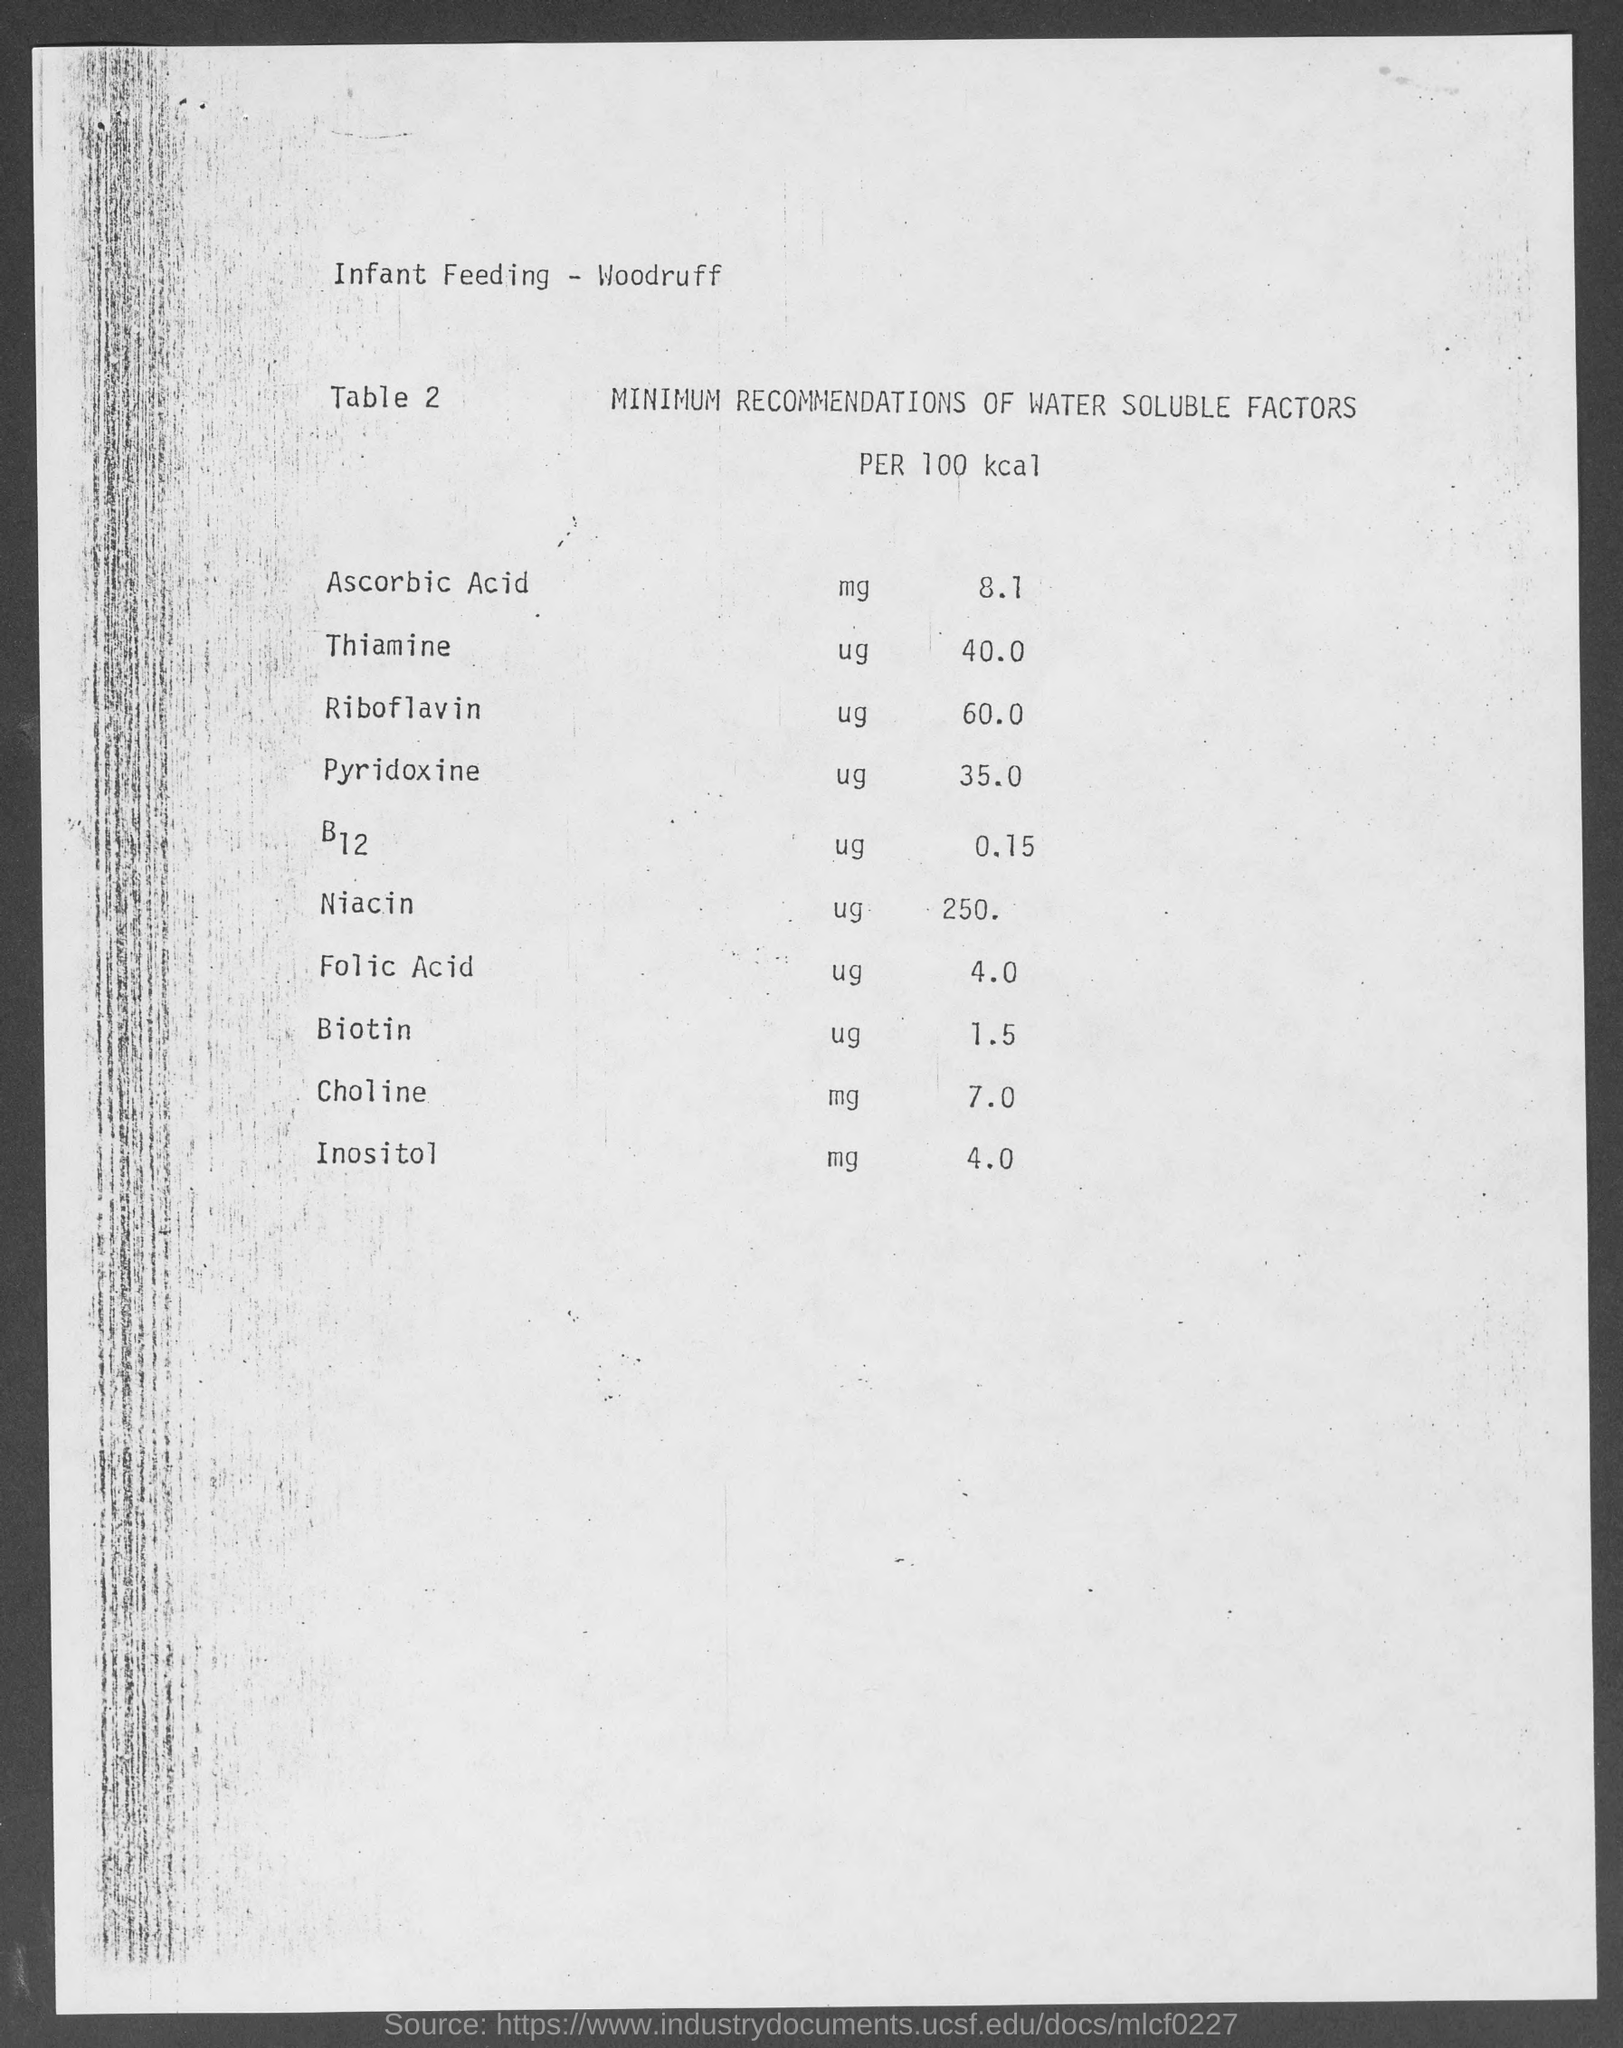What is the mg value of ascorbic acid?
Give a very brief answer. 8.1. What is the ug value of b12
Your response must be concise. 0.15. What is the mg value of choline?
Offer a terse response. 7.0. 